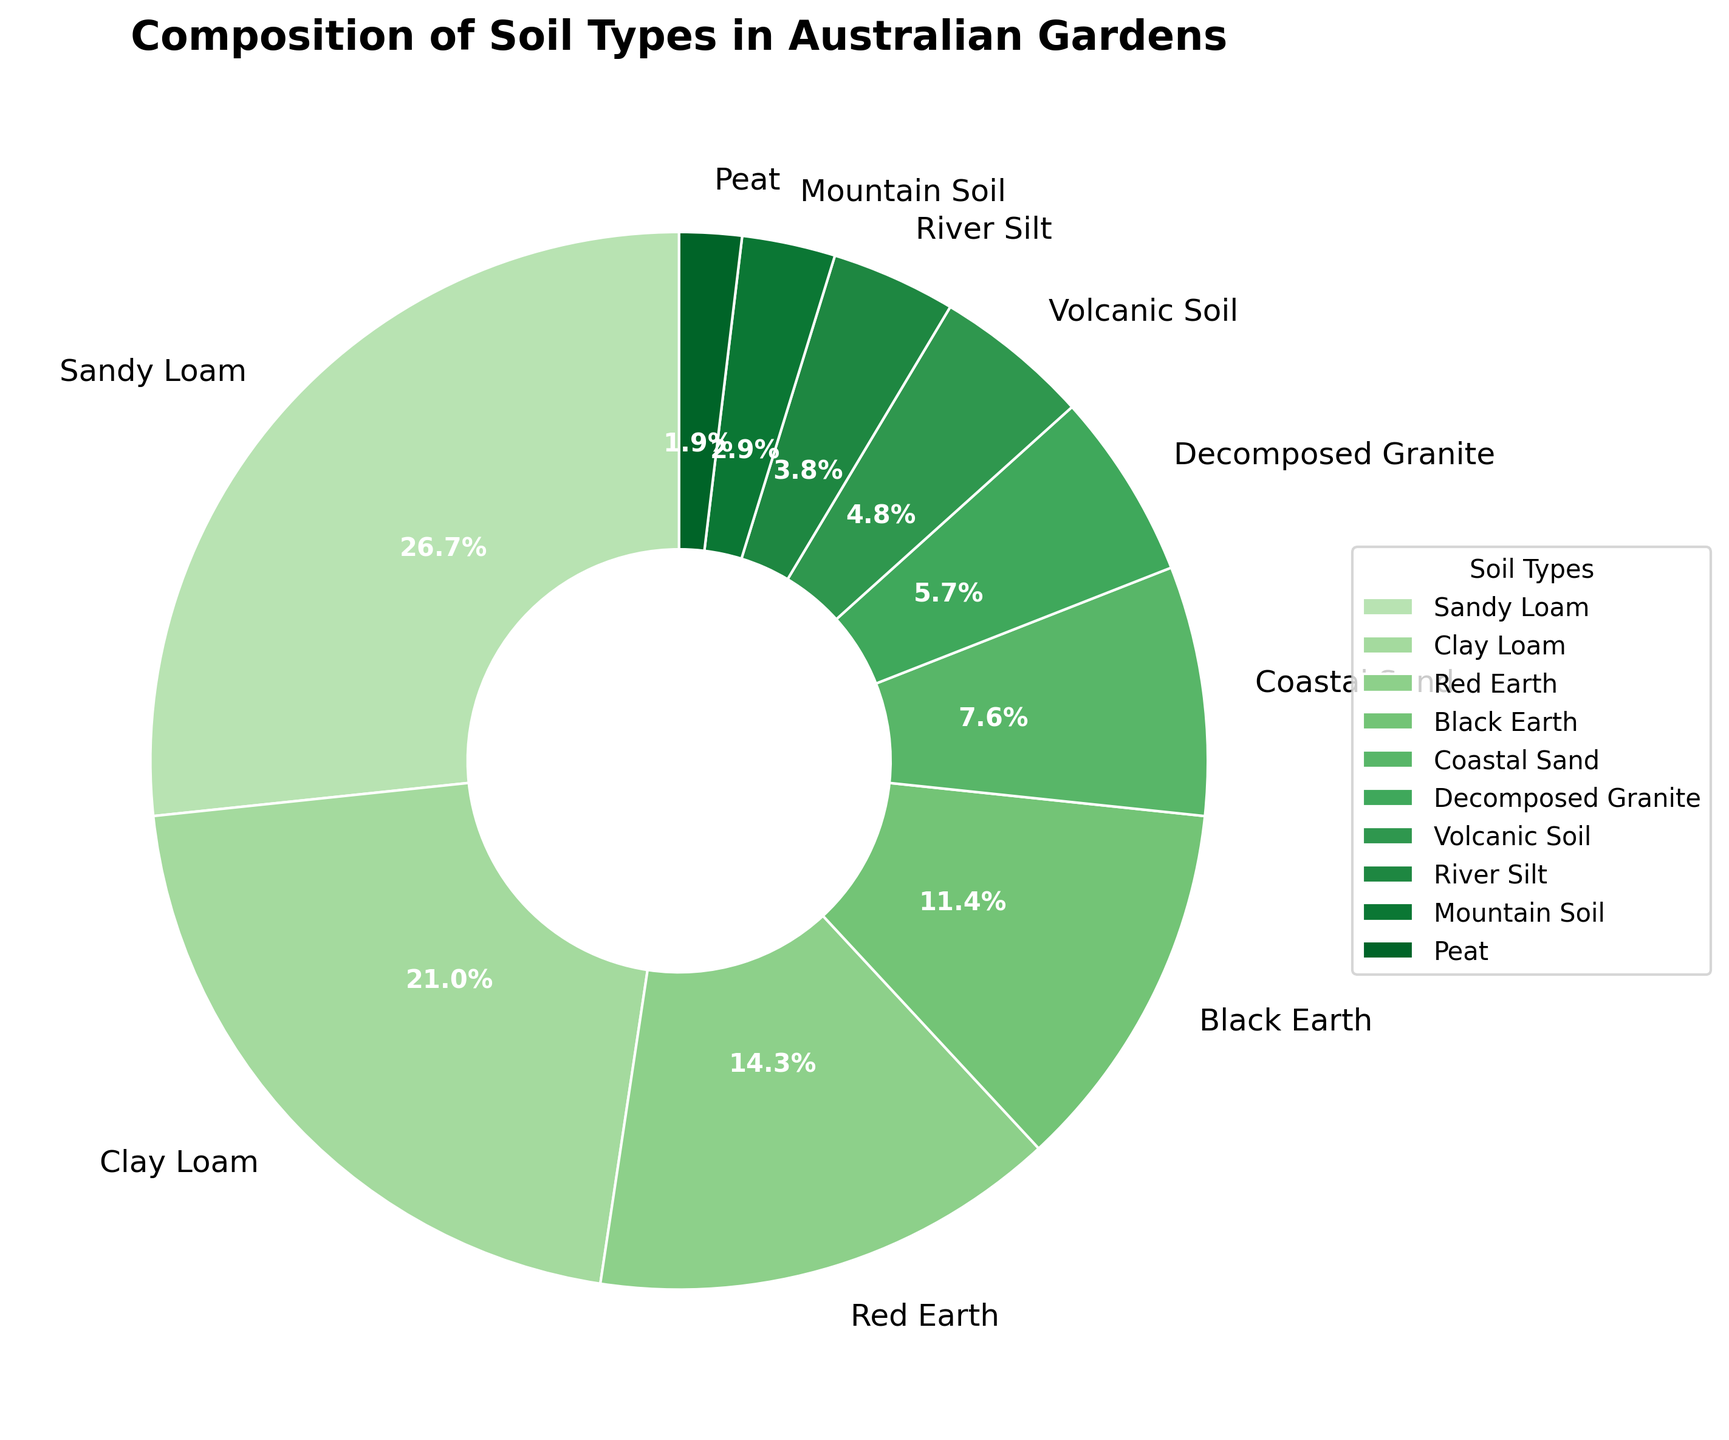What's the most common soil type in Australian gardens? By looking at the largest segment in the pie chart, which represents the soil type with the highest percentage, we see that Sandy Loam is the most common soil type.
Answer: Sandy Loam What's the combined percentage of Clay Loam and Red Earth soils? To find the combined percentage, add the proportions of Clay Loam (22%) and Red Earth (15%), which equals 22 + 15 = 37%.
Answer: 37% Which soil type is the least represented in Australian gardens? By observing the smallest segment in the pie chart, we see that Peat has the smallest percentage at 2%.
Answer: Peat Which is more prevalent, Coastal Sand or Decomposed Granite? Comparing the slices of Coastal Sand (8%) and Decomposed Granite (6%), we see that Coastal Sand is more prevalent.
Answer: Coastal Sand How does the percentage of Volcanic Soil compare to that of Mountain Soil? By comparing the sizes of the segments, Volcanic Soil (5%) is greater than Mountain Soil (3%).
Answer: Volcanic Soil > Mountain Soil If you sum up the percentages of River Silt and Mountain Soil, what do you get? Adding the percentages of River Silt (4%) and Mountain Soil (3%), we get 4 + 3 = 7%.
Answer: 7% Rank the top three soil types found in Australian gardens. The top three soil types can be determined by finding the three largest segments: Sandy Loam (28%), Clay Loam (22%), and Red Earth (15%).
Answer: Sandy Loam, Clay Loam, Red Earth What percentage of total soils in Australian gardens is non-loam? Non-loam soils are Red Earth, Black Earth, Coastal Sand, Decomposed Granite, Volcanic Soil, River Silt, Mountain Soil, and Peat. Their percentages are 15% + 12% + 8% + 6% + 5% + 4% + 3% + 2% = 55%.
Answer: 55% How much more common is Sandy Loam compared to Volcanic Soil? The difference in their percentages is calculated by subtracting Volcanic Soil (5%) from Sandy Loam (28%), giving us 28 - 5 = 23%.
Answer: 23% Which soil type contributes exactly half of the combined percentage of Clay Loam and Black Earth? First, calculate the combined percentage of Clay Loam (22%) and Black Earth (12%): 22 + 12 = 34%. Half of 34% is 17%, which is closest to Red Earth (15%). However, none of the types exactly match, so we answer with the nearest one.
Answer: Red Earth 